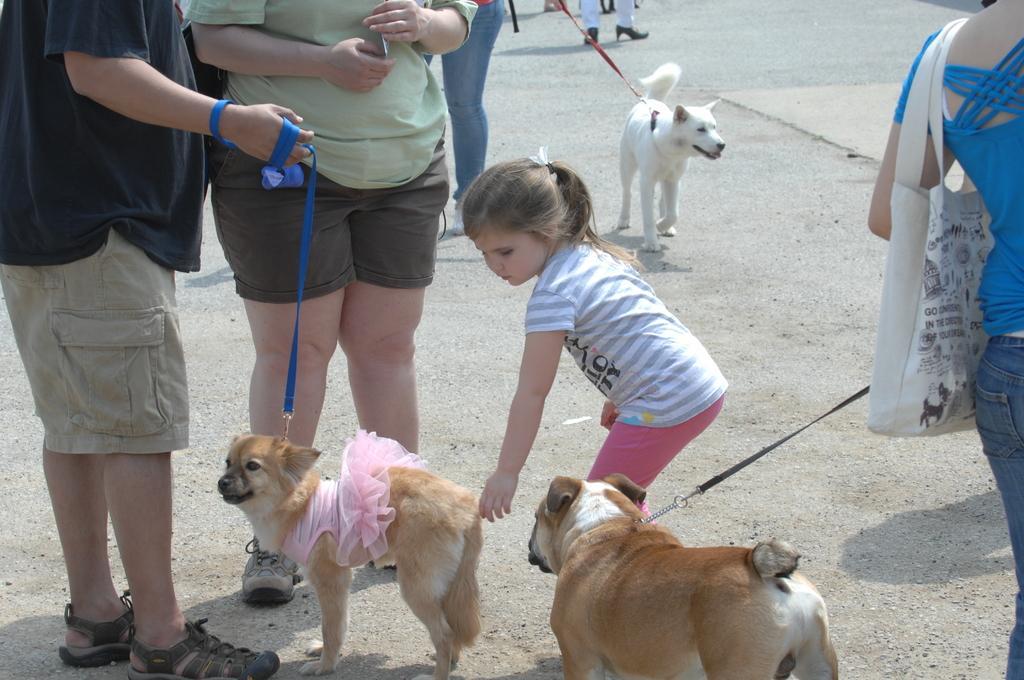Could you give a brief overview of what you see in this image? In this image I can see a crowd and three dogs on the road. This image is taken during a day on the road. 